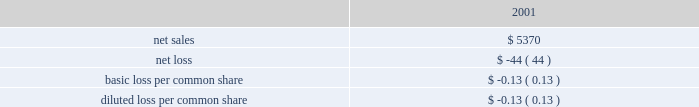61 of 93 is not necessarily indicative of the results of future operations that would have been achieved had the acquisitions taken place at the beginning of 2001 .
Pro forma information follows ( in millions , except per share amounts ) : .
Note 5 -- restructuring charges fiscal 2003 restructuring actions the company recorded total restructuring charges of approximately $ 26.8 million during the year ended september 27 , 2003 , including approximately $ 7.4 million in severance costs , a $ 5.0 million charge to write-off deferred compensation , $ 7.1 million in asset impairments and a $ 7.3 million charge for lease cancellations .
Of the $ 26.8 million , nearly all had been spent by the end of 2003 , except for approximately $ 400000 of severance costs and approximately $ 4.5 million related to operating lease costs on abandoned facilities .
During the third quarter of 2003 , approximately $ 500000 of the amount originally accrued for lease cancellations was determined to be in excess due to the sublease of a property sooner than originally estimated and an approximately $ 500000 shortfall was identified in the severance accrual due to higher than expected severance costs related to the closure of the company 2019s singapore manufacturing operations .
These adjustments had no net effect on reported operating expense .
During the second quarter of 2003 , the company 2019s management approved and initiated restructuring actions that resulted in recognition of a total restructuring charge of $ 2.8 million , including $ 2.4 million in severance costs and $ 400000 for asset write-offs and lease payments on an abandoned facility .
Actions taken in the second quarter were for the most part supplemental to actions initiated in the prior two quarters and focused on further headcount reductions in various sales and marketing functions in the company 2019s americas and europe operating segments and further reductions associated with powerschool-related activities in the americas operating segment , including an accrual for asset write-offs and lease payments on an abandoned facility .
The second quarter actions resulted in the termination of 93 employees , 92 were terminated prior to the end of 2003 .
During the first quarter of 2003 , the company 2019s management approved and initiated restructuring actions with a total cost of $ 24 million that resulted in the termination of manufacturing operations at the company-owned facility in singapore , further reductions in headcount resulting from the shift in powerschool product strategy that took place at the end of fiscal 2002 , and termination of various sales and marketing activities in the united states and europe .
These restructuring actions will ultimately result in the elimination of 260 positions worldwide , all but one of which were eliminated by the end of 2003 .
Closure of the company 2019s singapore manufacturing operations resulted in severance costs of $ 1.8 million and costs of $ 6.7 million to write-off manufacturing related fixed assets , whose use ceased during the first quarter .
Powerschool related costs included severance of approximately $ 550000 and recognition of $ 5 million of previously deferred stock compensation that arose when powerschool was acquired by the company in 2001 related to certain powerschool employee stockholders who were terminated in the first quarter of 2003 .
Termination of sales and marketing activities and employees , principally in the united states and europe , resulted in severance costs of $ 2.8 million and accrual of costs associated with operating leases on closed facilities of $ 6.7 million .
The total net restructuring charge of $ 23 million recognized during the first quarter of 2003 also reflects the reversal of $ 600000 of unused restructuring accrual originally made during the first quarter of 2002 .
Except for certain costs associated with operating leases on closed facilities , the company currently anticipates that all of the remaining accrual for severance costs of approximately $ 400000 will be spent by the end of the first quarter of fiscal 2004. .
What percentage of the total restructuring charges during the year ended september 27 , 2003 were severance costs? 
Computations: (7.4 / 26.8)
Answer: 0.27612. 